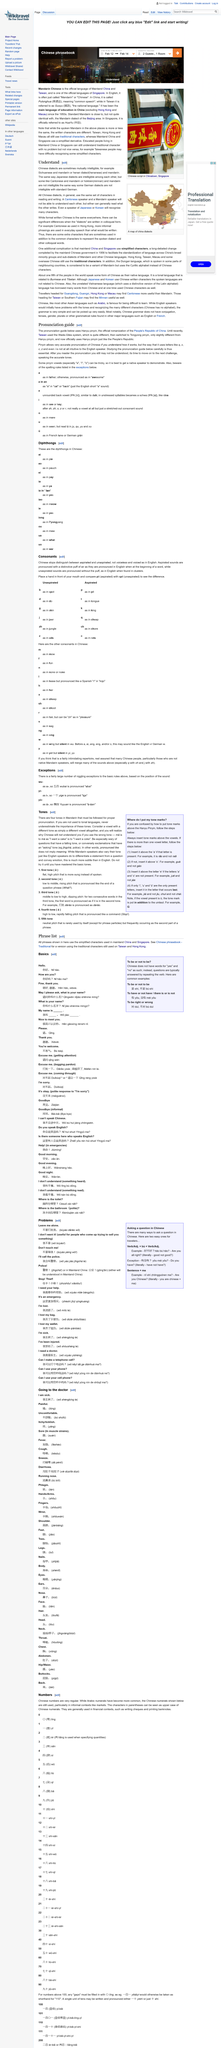Draw attention to some important aspects in this diagram. The use of characters is uniform across all Chinese dialects. Chinese dialects are not always mutually intelligible, as they may be understandable when spoken but not when written or read. Before using the Wade-Giles system, Taiwan utilized a previous system for naming and transcribing Chinese characters. Hanyu Pinyin is the official romanization system used by the People's Republic of China to represent Chinese language characters using the Roman alphabet. Tongyong Pinyin was a system previously used in Taiwan for transcribing Standard Chinese into the Roman alphabet. 